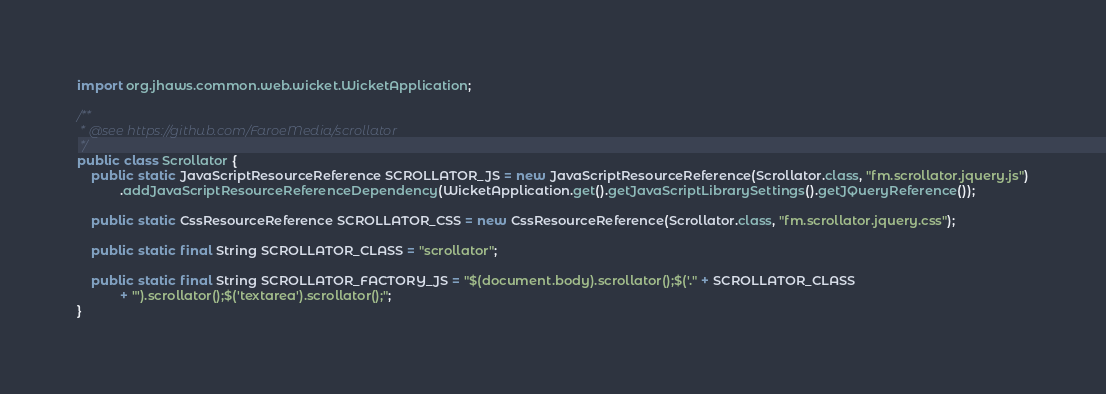Convert code to text. <code><loc_0><loc_0><loc_500><loc_500><_Java_>import org.jhaws.common.web.wicket.WicketApplication;

/**
 * @see https://github.com/FaroeMedia/scrollator
 */
public class Scrollator {
    public static JavaScriptResourceReference SCROLLATOR_JS = new JavaScriptResourceReference(Scrollator.class, "fm.scrollator.jquery.js")
            .addJavaScriptResourceReferenceDependency(WicketApplication.get().getJavaScriptLibrarySettings().getJQueryReference());

    public static CssResourceReference SCROLLATOR_CSS = new CssResourceReference(Scrollator.class, "fm.scrollator.jquery.css");

    public static final String SCROLLATOR_CLASS = "scrollator";

    public static final String SCROLLATOR_FACTORY_JS = "$(document.body).scrollator();$('." + SCROLLATOR_CLASS
            + "').scrollator();$('textarea').scrollator();";
}
</code> 